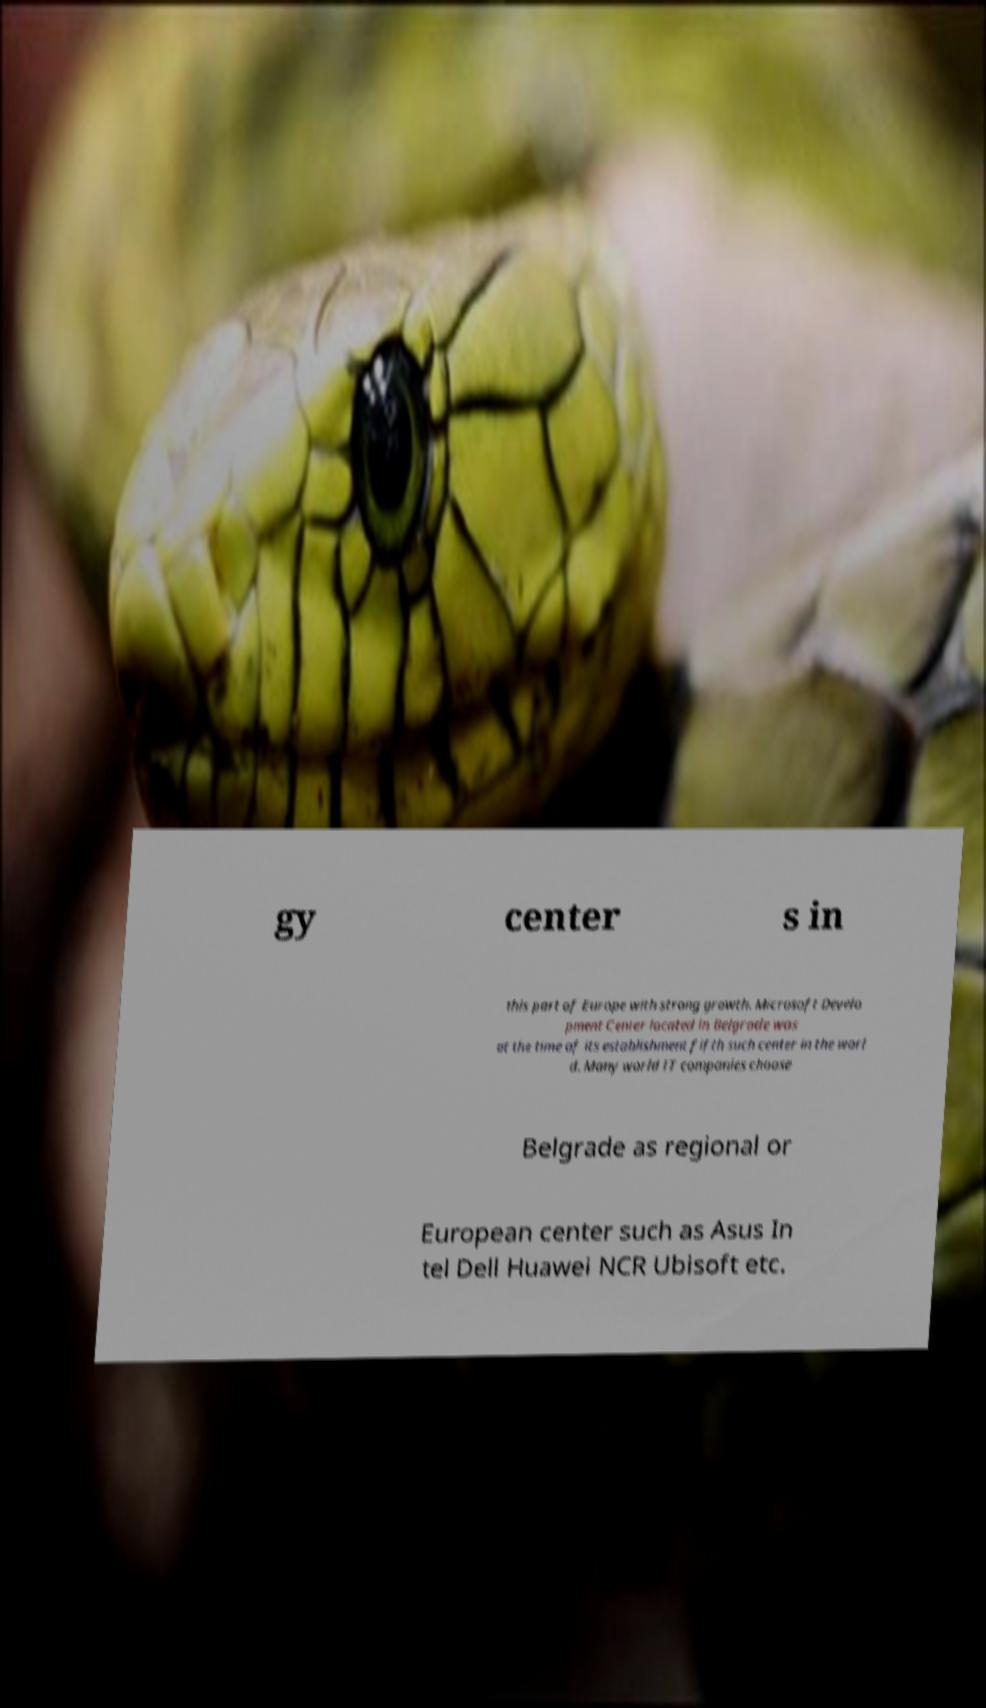There's text embedded in this image that I need extracted. Can you transcribe it verbatim? gy center s in this part of Europe with strong growth. Microsoft Develo pment Center located in Belgrade was at the time of its establishment fifth such center in the worl d. Many world IT companies choose Belgrade as regional or European center such as Asus In tel Dell Huawei NCR Ubisoft etc. 